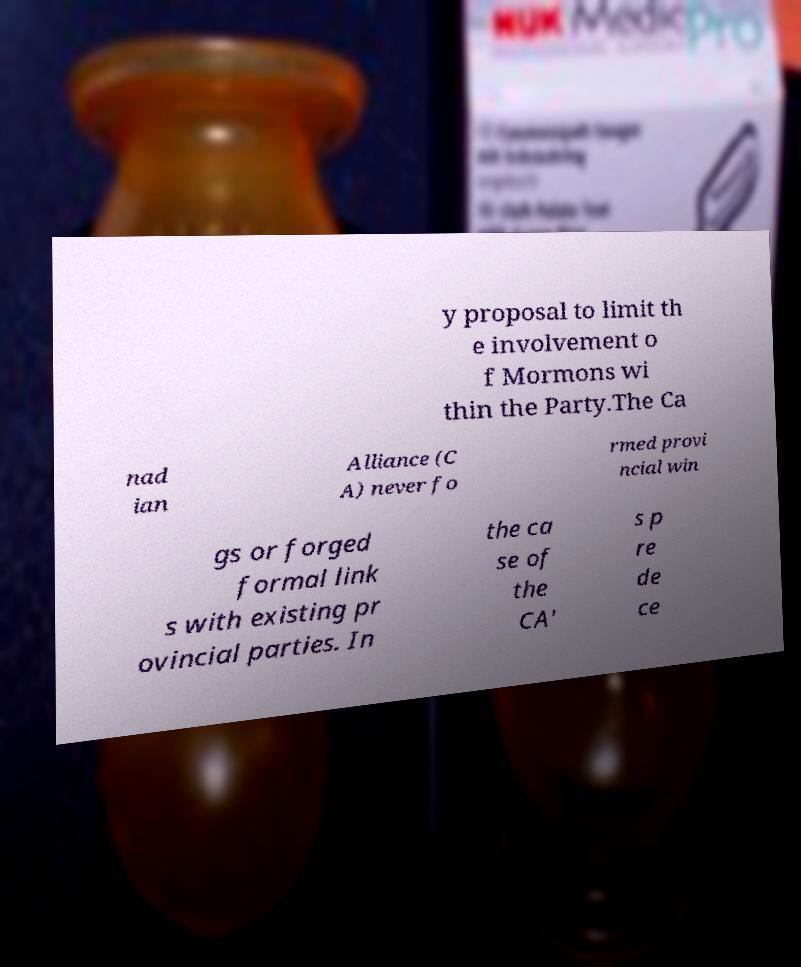For documentation purposes, I need the text within this image transcribed. Could you provide that? y proposal to limit th e involvement o f Mormons wi thin the Party.The Ca nad ian Alliance (C A) never fo rmed provi ncial win gs or forged formal link s with existing pr ovincial parties. In the ca se of the CA' s p re de ce 